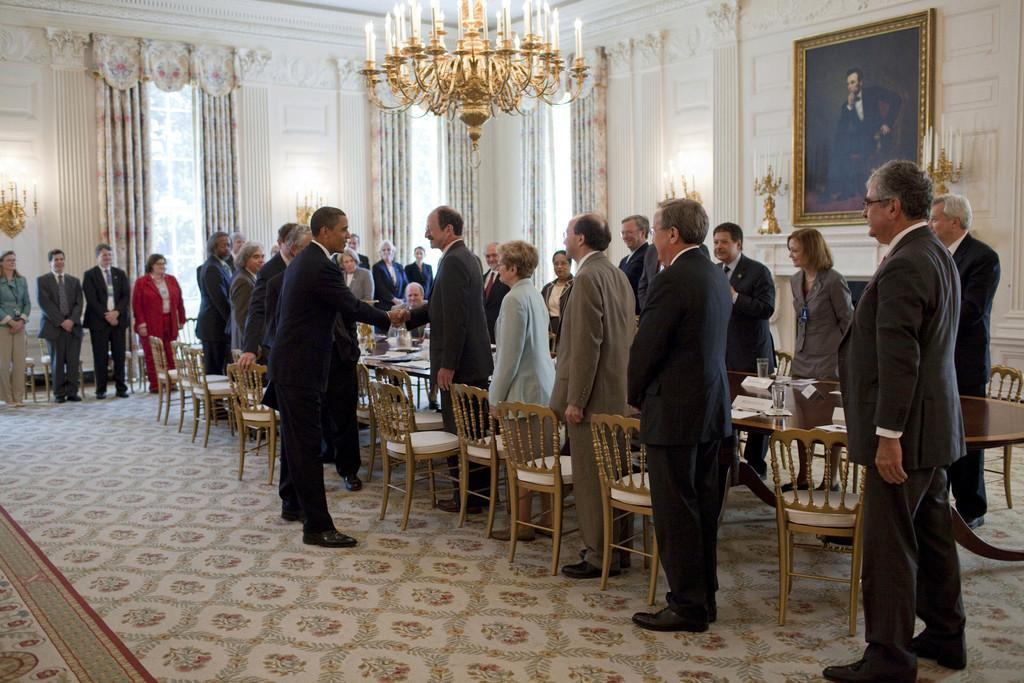What is the color of the wall in the image? The wall in the image is white. What type of window treatment is present in the image? Curtains are present in the image. What type of lighting fixture is visible in the image? A chandelier is visible in the image. What type of decorative items can be seen in the image? There are photo frames in the image. What type of furniture is present in the image? Chairs and tables are visible in the image. What type of people are present in the image? There are people standing on the floor in the image. What type of yarn is being used to create the structure in the image? There is no structure made of yarn present in the image. How many rings are visible on the people's fingers in the image? There is no mention of rings on anyone's fingers in the image. 